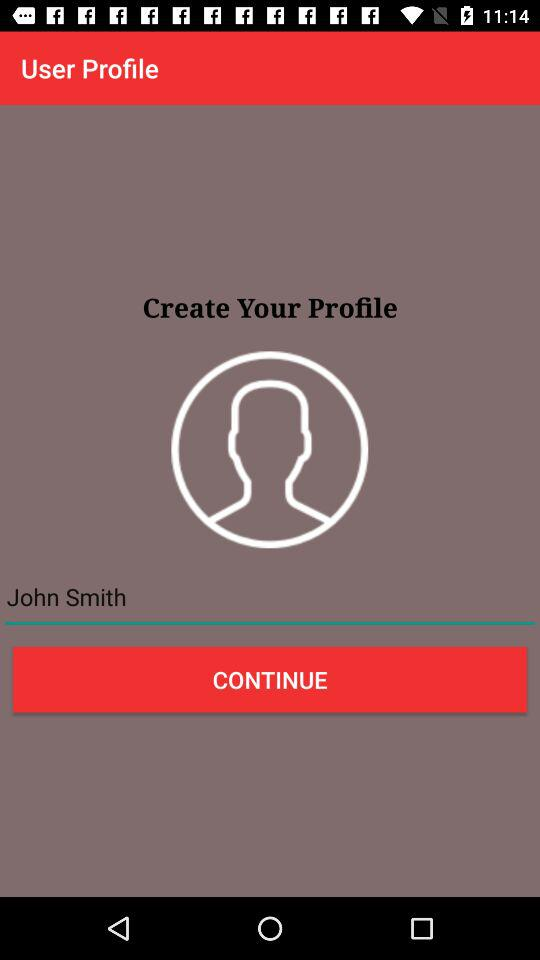What is the name of the user? The name of the user is John Smith. 